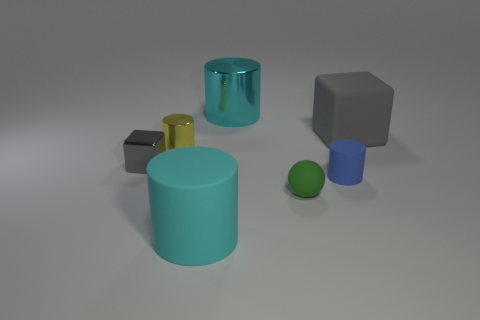Subtract all cylinders. How many objects are left? 3 Add 1 green objects. How many objects exist? 8 Add 7 big shiny objects. How many big shiny objects are left? 8 Add 2 big gray metallic cubes. How many big gray metallic cubes exist? 2 Subtract 0 brown cylinders. How many objects are left? 7 Subtract all red balls. Subtract all small yellow metallic objects. How many objects are left? 6 